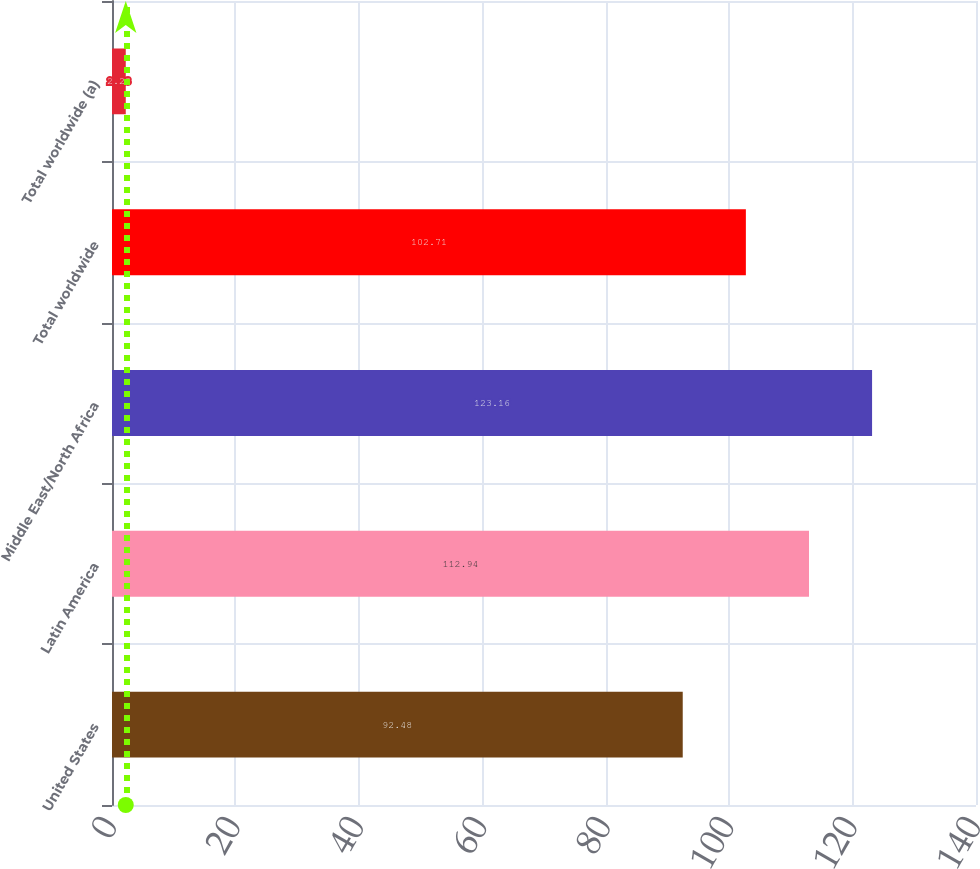<chart> <loc_0><loc_0><loc_500><loc_500><bar_chart><fcel>United States<fcel>Latin America<fcel>Middle East/North Africa<fcel>Total worldwide<fcel>Total worldwide (a)<nl><fcel>92.48<fcel>112.94<fcel>123.16<fcel>102.71<fcel>2.23<nl></chart> 